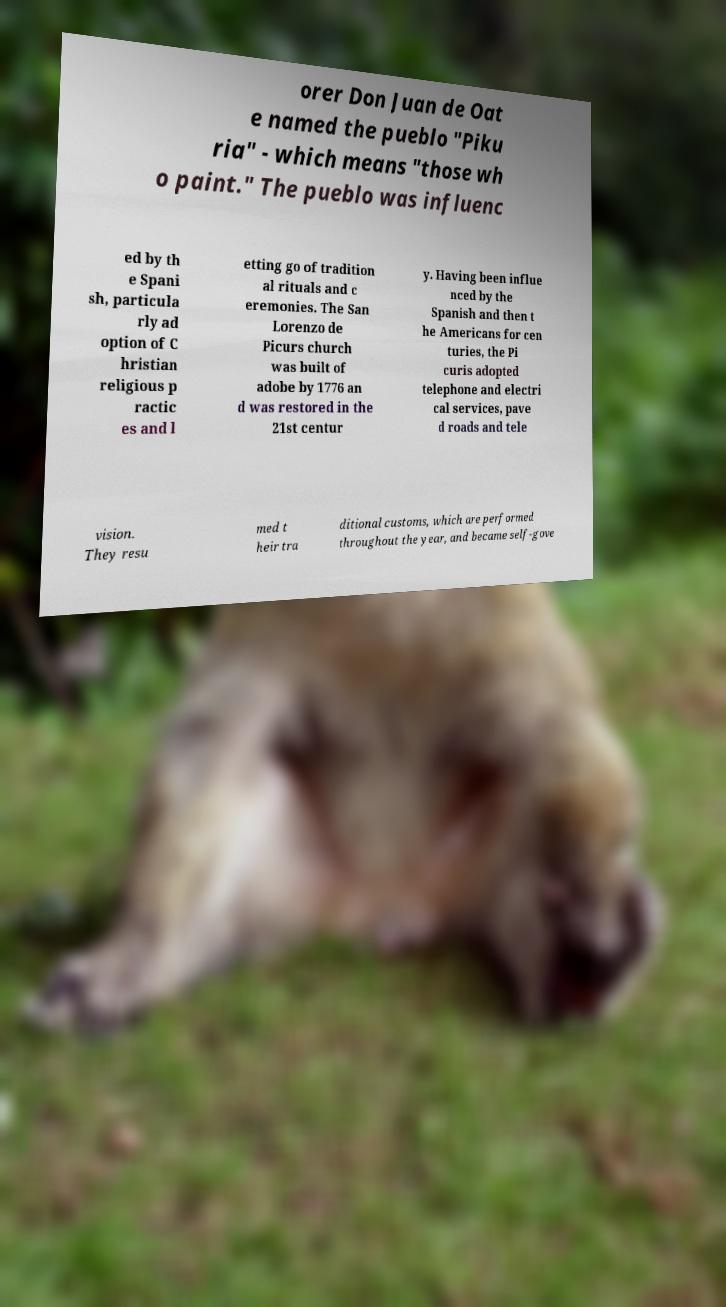There's text embedded in this image that I need extracted. Can you transcribe it verbatim? orer Don Juan de Oat e named the pueblo "Piku ria" - which means "those wh o paint." The pueblo was influenc ed by th e Spani sh, particula rly ad option of C hristian religious p ractic es and l etting go of tradition al rituals and c eremonies. The San Lorenzo de Picurs church was built of adobe by 1776 an d was restored in the 21st centur y. Having been influe nced by the Spanish and then t he Americans for cen turies, the Pi curis adopted telephone and electri cal services, pave d roads and tele vision. They resu med t heir tra ditional customs, which are performed throughout the year, and became self-gove 